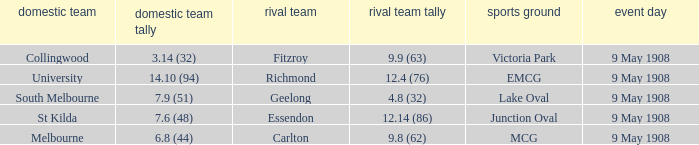Name the home team score for south melbourne home team 7.9 (51). 